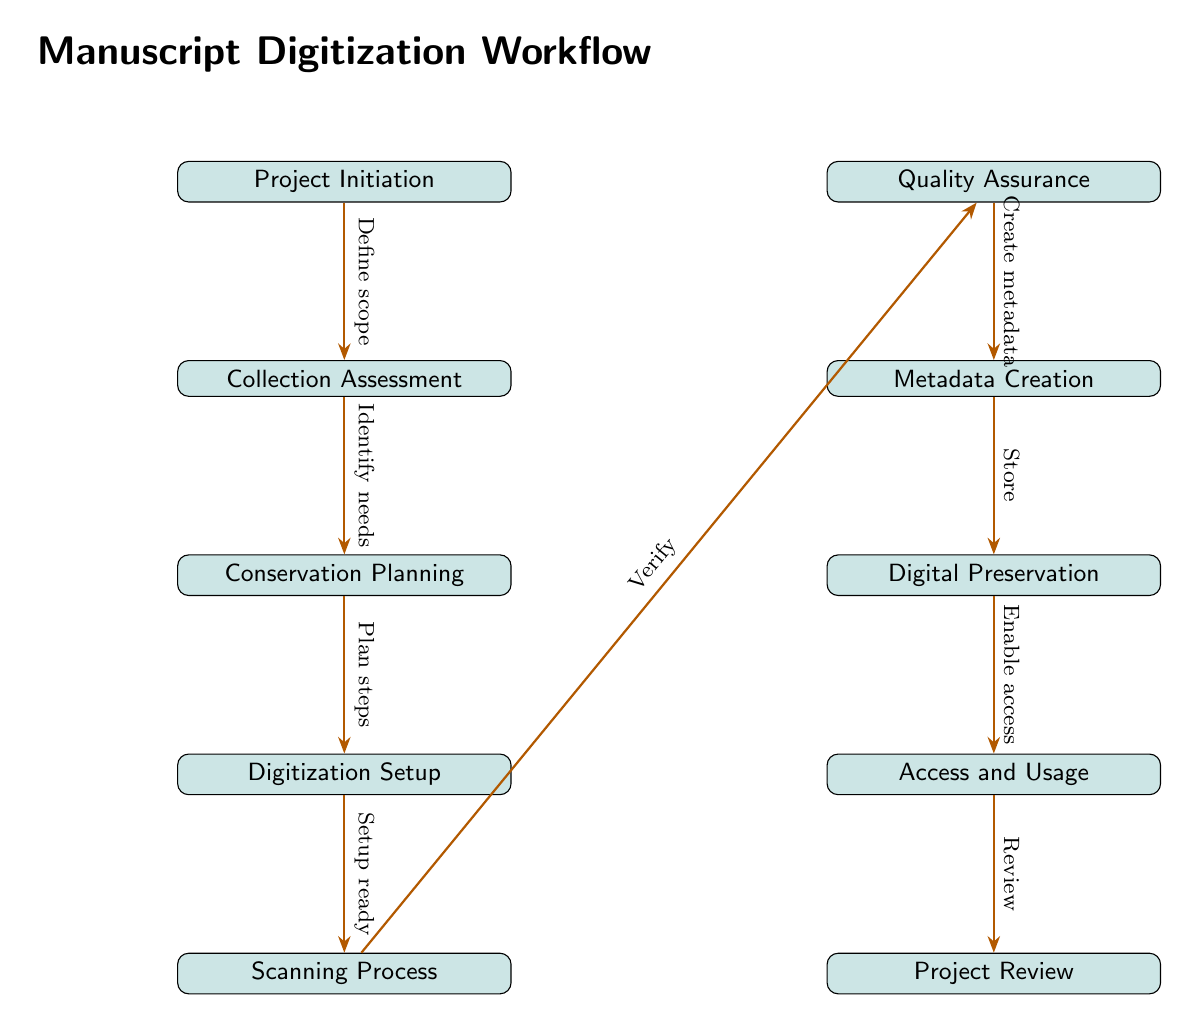What is the first step in the manuscript digitization workflow? According to the diagram, the first step in the manuscript digitization workflow is labeled "Project Initiation," indicating the starting point of the process.
Answer: Project Initiation How many nodes are there in the workflow? By counting the boxes representing each step or stage in the digitization workflow, we find that there are a total of ten nodes labeled from Project Initiation to Project Review.
Answer: 10 What is the last node in the workflow? The last node in the workflow, positioned at the bottom of the diagram, is labeled "Project Review," signifying the concluding stage of the digitization process.
Answer: Project Review What follows "Scanning Process" in the workflow? The node that directly follows "Scanning Process" is labeled "Quality Assurance," indicating that after scanning, the next action is to verify the digitized materials.
Answer: Quality Assurance What is the relationship between "Collection Assessment" and "Conservation Planning"? The diagram shows an arrow directing from "Collection Assessment" to "Conservation Planning," indicating that the needs identified during the assessment guide the planning of conservation measures.
Answer: Identify needs What action occurs after "Create metadata"? The action that follows "Create metadata" in the workflow is labeled "Digital Preservation," indicating that once metadata is created, the next step is to ensure the preservation of digital files.
Answer: Digital Preservation How many arrows are present in the workflow chart? By examining the diagram, we can count the arrows, which connect each step, leading to a total of nine arrows in the workflow chart.
Answer: 9 Which node represents enabling access to the digitized manuscripts? The node that represents the action of granting access to the digitized manuscripts is labeled "Access and Usage," indicating where users can engage with the digital materials.
Answer: Access and Usage What does "Setup ready" refer to in the workflow? In the context of the diagram, "Setup ready" is associated with the transition from "Digitization Setup" to "Scanning Process," indicating that the setup needs to be completed before scanning can commence.
Answer: Scanning Process What is the purpose of the "Quality Assurance" node in the workflow? The purpose of the "Quality Assurance" node is to ensure that the quality of the digitized materials meets specified standards before moving to the metadata creation stage.
Answer: Ensure quality 